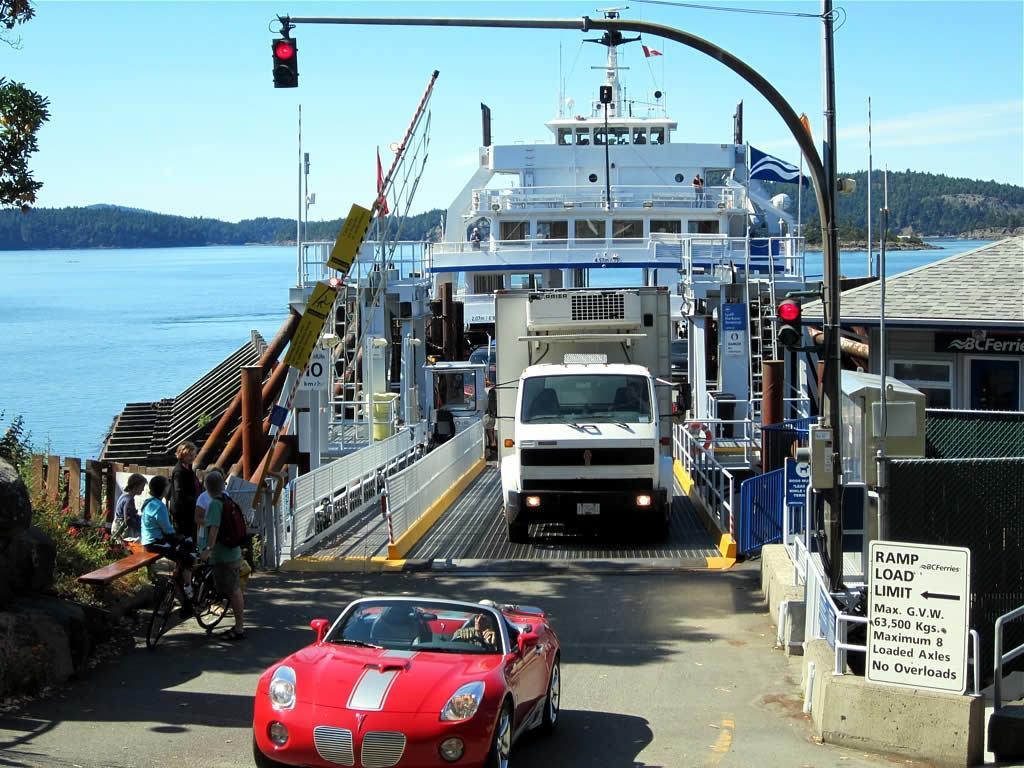Could you give a brief overview of what you see in this image? This image is clicked on the road. There is a car moving on the road. To the left there a few people standing. There is a person holding a bicycle. Behind the car there is a truck. Beside the truck there is a railing. Behind the railing there is a cabin. Behind the truck there is a ship. There is water in the image. In the background there are mountains. At the top there is the sky. To the right there is a board to the railing. There is text on the board. Beside the board there is a traffic signal pole. 